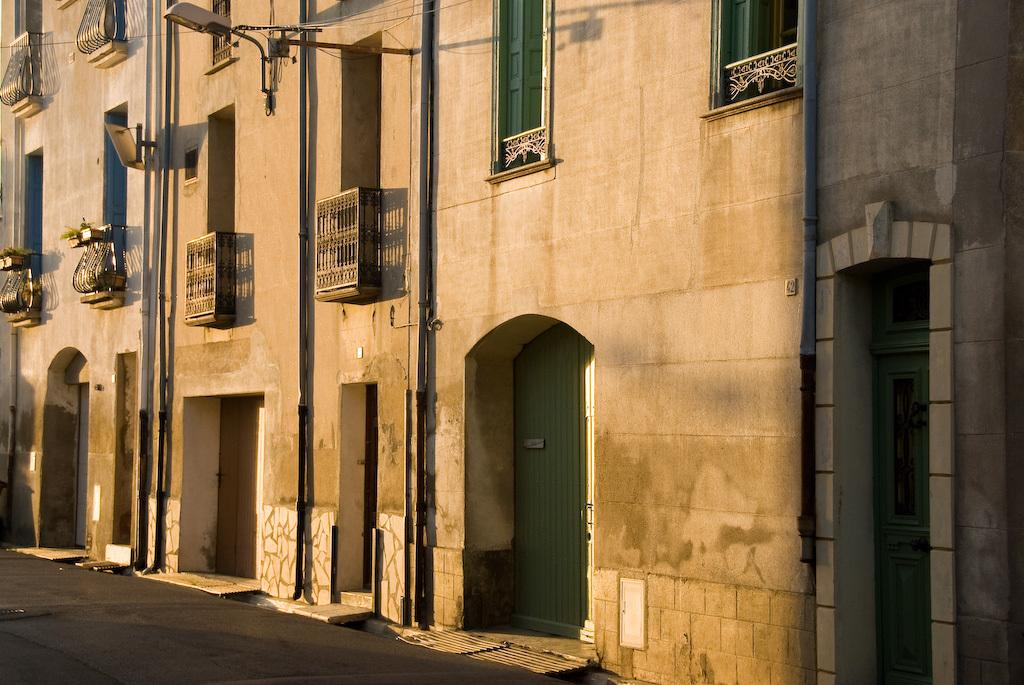What type of structure is present in the image? There is a building in the image. What features can be seen on the building? The building has pipes and windows. Is there any indication of activity inside the building? Yes, light is visible in the building. What is located in front of the building? There is a road in front of the building. What type of soap is being used to clean the windows in the image? There is no indication of soap or window cleaning in the image; the windows are simply visible on the building. 